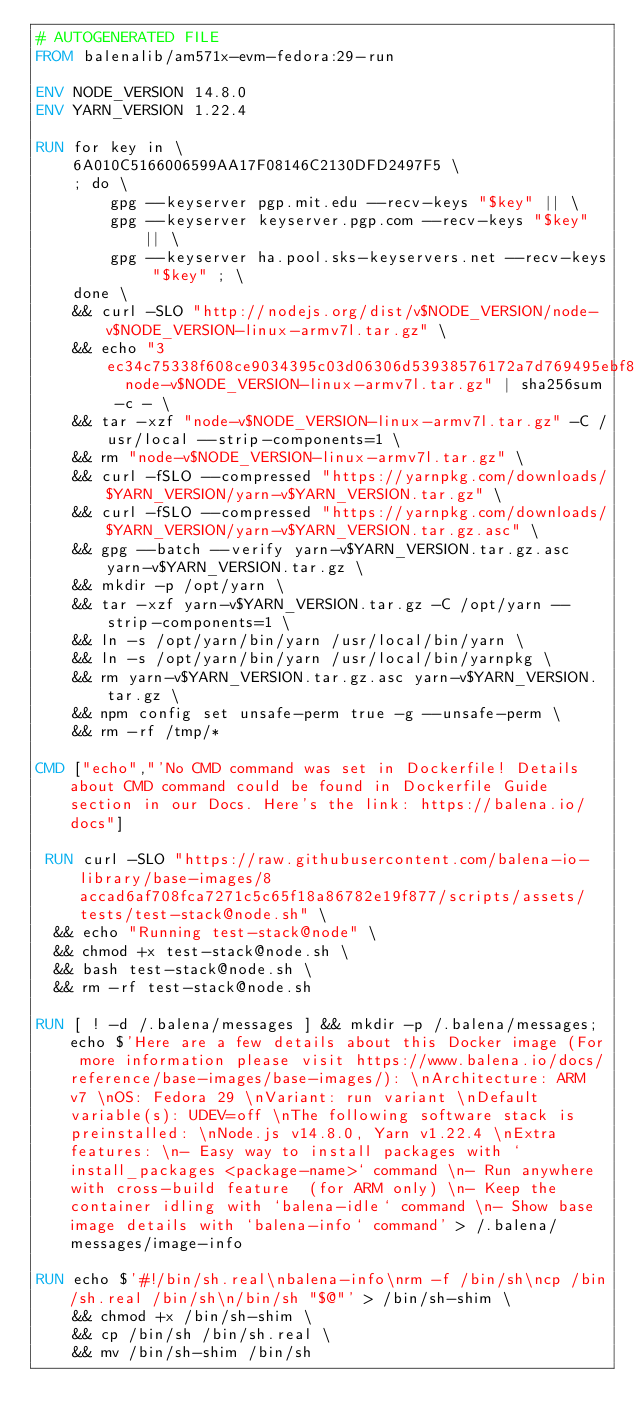<code> <loc_0><loc_0><loc_500><loc_500><_Dockerfile_># AUTOGENERATED FILE
FROM balenalib/am571x-evm-fedora:29-run

ENV NODE_VERSION 14.8.0
ENV YARN_VERSION 1.22.4

RUN for key in \
	6A010C5166006599AA17F08146C2130DFD2497F5 \
	; do \
		gpg --keyserver pgp.mit.edu --recv-keys "$key" || \
		gpg --keyserver keyserver.pgp.com --recv-keys "$key" || \
		gpg --keyserver ha.pool.sks-keyservers.net --recv-keys "$key" ; \
	done \
	&& curl -SLO "http://nodejs.org/dist/v$NODE_VERSION/node-v$NODE_VERSION-linux-armv7l.tar.gz" \
	&& echo "3ec34c75338f608ce9034395c03d06306d53938576172a7d769495ebf8ff512b  node-v$NODE_VERSION-linux-armv7l.tar.gz" | sha256sum -c - \
	&& tar -xzf "node-v$NODE_VERSION-linux-armv7l.tar.gz" -C /usr/local --strip-components=1 \
	&& rm "node-v$NODE_VERSION-linux-armv7l.tar.gz" \
	&& curl -fSLO --compressed "https://yarnpkg.com/downloads/$YARN_VERSION/yarn-v$YARN_VERSION.tar.gz" \
	&& curl -fSLO --compressed "https://yarnpkg.com/downloads/$YARN_VERSION/yarn-v$YARN_VERSION.tar.gz.asc" \
	&& gpg --batch --verify yarn-v$YARN_VERSION.tar.gz.asc yarn-v$YARN_VERSION.tar.gz \
	&& mkdir -p /opt/yarn \
	&& tar -xzf yarn-v$YARN_VERSION.tar.gz -C /opt/yarn --strip-components=1 \
	&& ln -s /opt/yarn/bin/yarn /usr/local/bin/yarn \
	&& ln -s /opt/yarn/bin/yarn /usr/local/bin/yarnpkg \
	&& rm yarn-v$YARN_VERSION.tar.gz.asc yarn-v$YARN_VERSION.tar.gz \
	&& npm config set unsafe-perm true -g --unsafe-perm \
	&& rm -rf /tmp/*

CMD ["echo","'No CMD command was set in Dockerfile! Details about CMD command could be found in Dockerfile Guide section in our Docs. Here's the link: https://balena.io/docs"]

 RUN curl -SLO "https://raw.githubusercontent.com/balena-io-library/base-images/8accad6af708fca7271c5c65f18a86782e19f877/scripts/assets/tests/test-stack@node.sh" \
  && echo "Running test-stack@node" \
  && chmod +x test-stack@node.sh \
  && bash test-stack@node.sh \
  && rm -rf test-stack@node.sh 

RUN [ ! -d /.balena/messages ] && mkdir -p /.balena/messages; echo $'Here are a few details about this Docker image (For more information please visit https://www.balena.io/docs/reference/base-images/base-images/): \nArchitecture: ARM v7 \nOS: Fedora 29 \nVariant: run variant \nDefault variable(s): UDEV=off \nThe following software stack is preinstalled: \nNode.js v14.8.0, Yarn v1.22.4 \nExtra features: \n- Easy way to install packages with `install_packages <package-name>` command \n- Run anywhere with cross-build feature  (for ARM only) \n- Keep the container idling with `balena-idle` command \n- Show base image details with `balena-info` command' > /.balena/messages/image-info

RUN echo $'#!/bin/sh.real\nbalena-info\nrm -f /bin/sh\ncp /bin/sh.real /bin/sh\n/bin/sh "$@"' > /bin/sh-shim \
	&& chmod +x /bin/sh-shim \
	&& cp /bin/sh /bin/sh.real \
	&& mv /bin/sh-shim /bin/sh</code> 